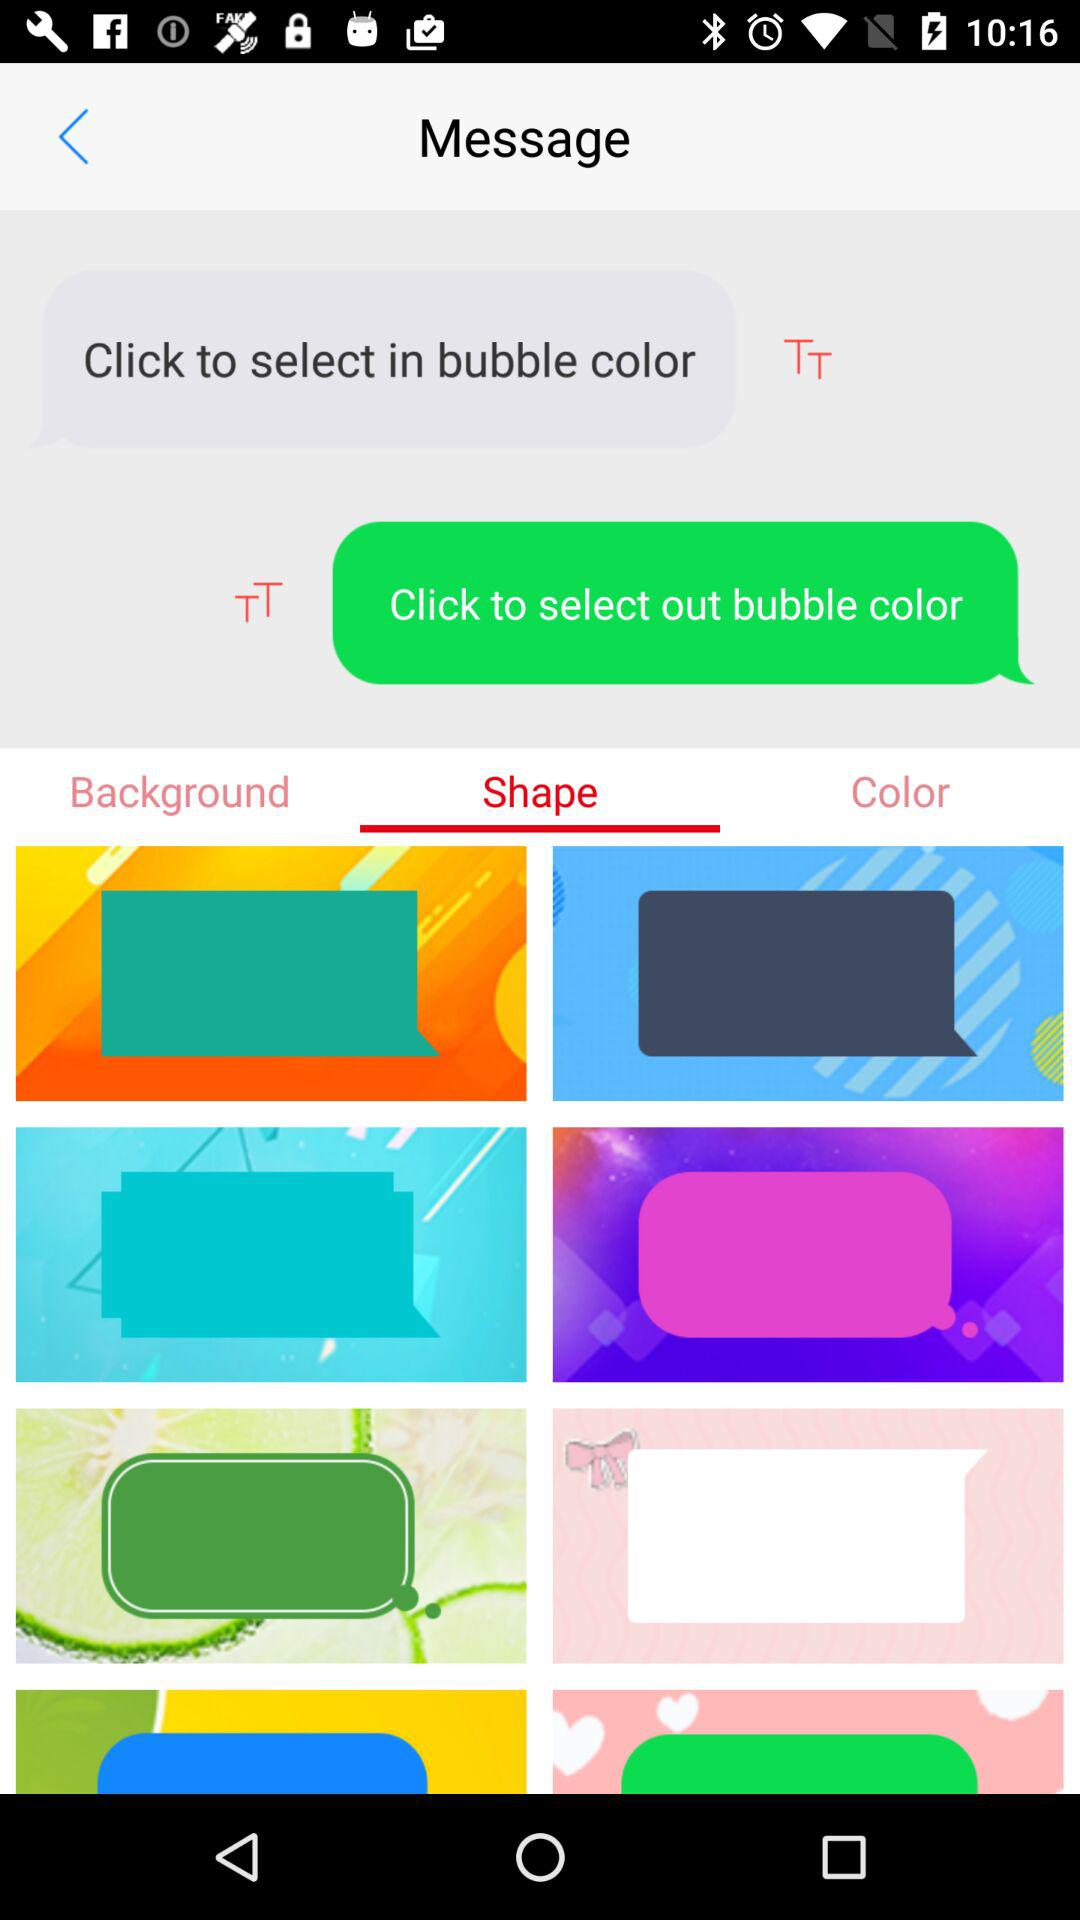Which tab is selected? The selected tab is "Shape". 